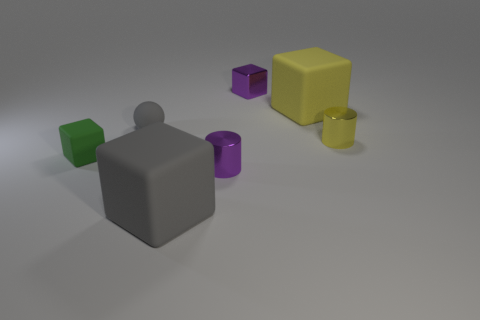How many objects are shiny objects that are behind the small gray matte ball or small purple things that are to the right of the tiny purple cylinder?
Offer a terse response. 1. What is the size of the gray rubber block that is in front of the tiny metal thing right of the purple block?
Give a very brief answer. Large. Is the color of the cylinder to the left of the large yellow matte thing the same as the tiny shiny block?
Ensure brevity in your answer.  Yes. Are there any purple things of the same shape as the large yellow thing?
Provide a succinct answer. Yes. The rubber sphere that is the same size as the purple metallic cube is what color?
Your answer should be very brief. Gray. There is a matte thing that is behind the gray sphere; how big is it?
Make the answer very short. Large. Is there a metallic object in front of the big rubber cube that is behind the tiny ball?
Give a very brief answer. Yes. Does the purple object that is in front of the yellow cylinder have the same material as the green object?
Your answer should be compact. No. How many cubes are both in front of the purple cylinder and to the left of the tiny rubber sphere?
Give a very brief answer. 0. What number of tiny green things are made of the same material as the small gray ball?
Provide a short and direct response. 1. 